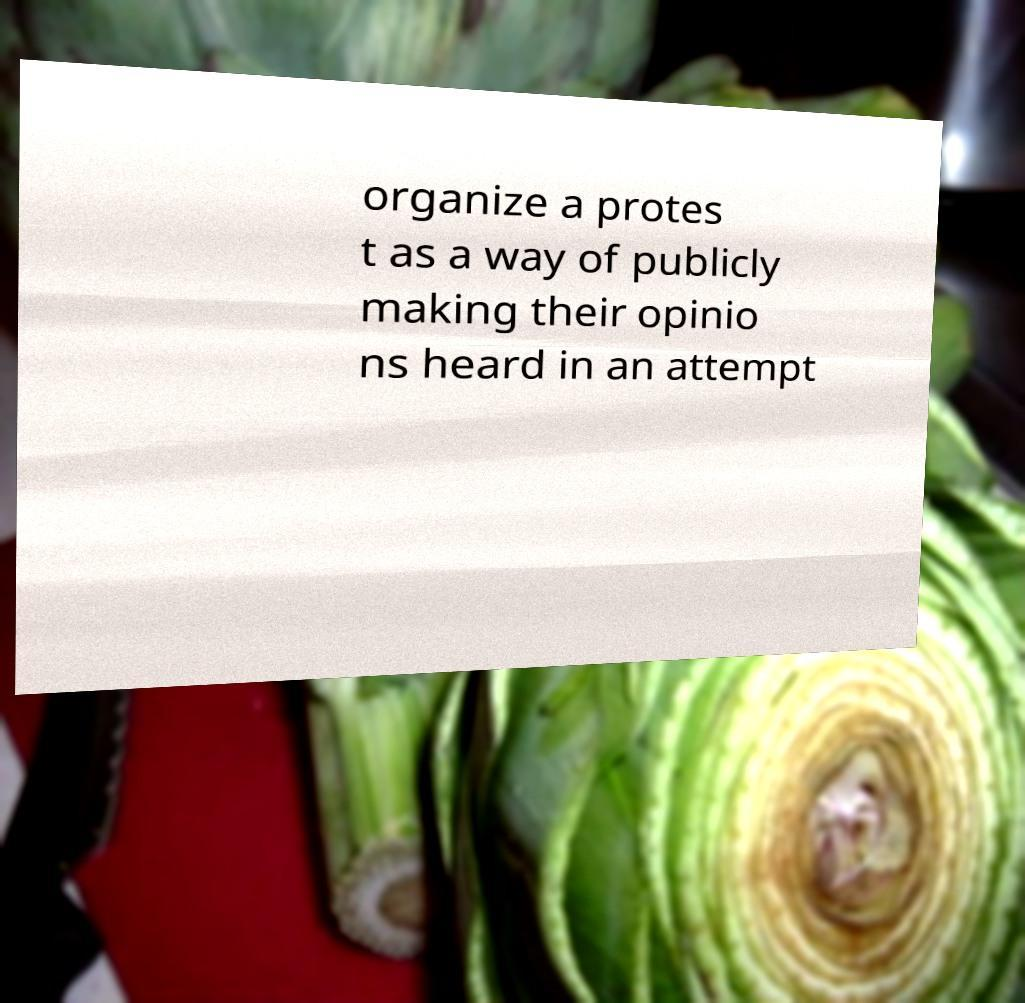Could you extract and type out the text from this image? organize a protes t as a way of publicly making their opinio ns heard in an attempt 